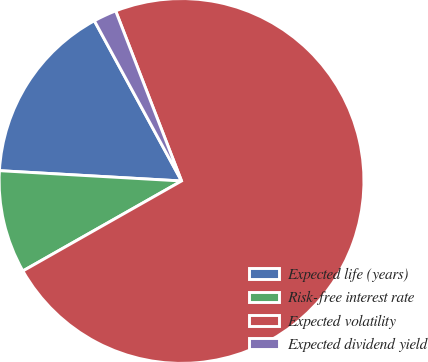Convert chart to OTSL. <chart><loc_0><loc_0><loc_500><loc_500><pie_chart><fcel>Expected life (years)<fcel>Risk-free interest rate<fcel>Expected volatility<fcel>Expected dividend yield<nl><fcel>16.17%<fcel>9.11%<fcel>72.67%<fcel>2.05%<nl></chart> 